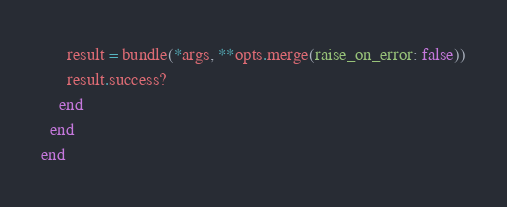Convert code to text. <code><loc_0><loc_0><loc_500><loc_500><_Ruby_>      result = bundle(*args, **opts.merge(raise_on_error: false))
      result.success?
    end
  end
end
</code> 